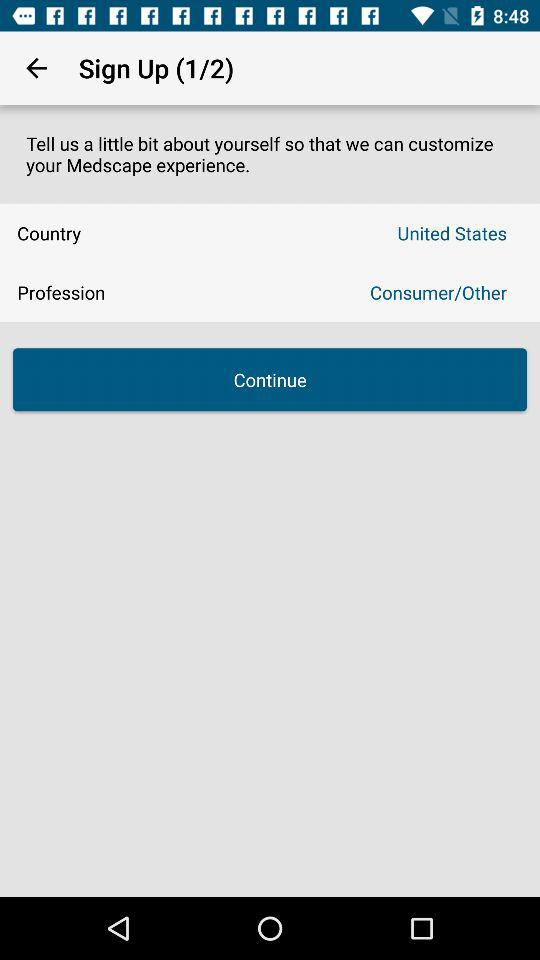What is the country name? The country name is the United States. 